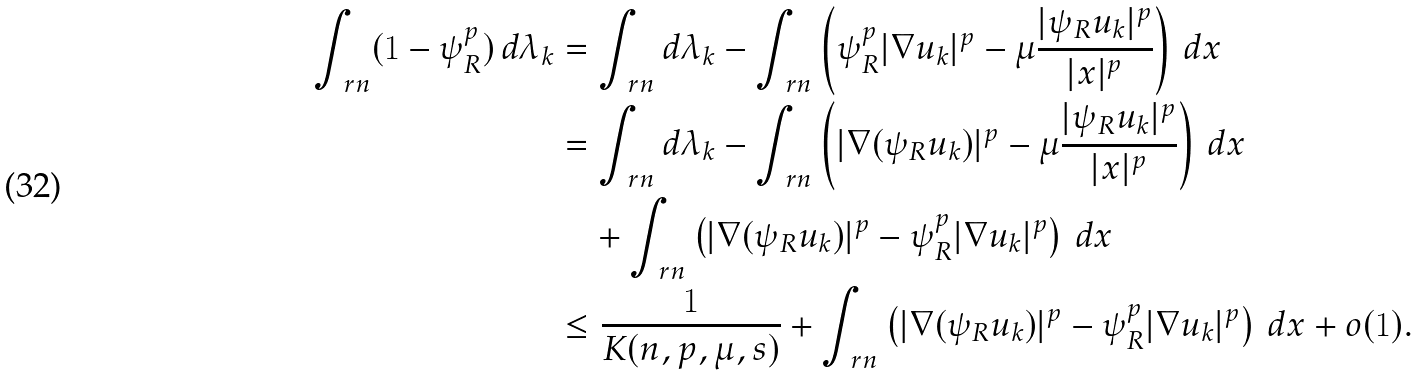<formula> <loc_0><loc_0><loc_500><loc_500>\int _ { \ r n } ( 1 - \psi _ { R } ^ { p } ) \, d \lambda _ { k } & = \int _ { \ r n } d \lambda _ { k } - \int _ { \ r n } \left ( \psi _ { R } ^ { p } | \nabla u _ { k } | ^ { p } - \mu \frac { | \psi _ { R } u _ { k } | ^ { p } } { | x | ^ { p } } \right ) \, d x \\ & = \int _ { \ r n } d \lambda _ { k } - \int _ { \ r n } \left ( | \nabla ( \psi _ { R } u _ { k } ) | ^ { p } - \mu \frac { | \psi _ { R } u _ { k } | ^ { p } } { | x | ^ { p } } \right ) \, d x \\ & \quad + \int _ { \ r n } \left ( | \nabla ( \psi _ { R } u _ { k } ) | ^ { p } - \psi _ { R } ^ { p } | \nabla u _ { k } | ^ { p } \right ) \, d x \\ & \leq \frac { 1 } { K ( n , p , \mu , s ) } + \int _ { \ r n } \left ( | \nabla ( \psi _ { R } u _ { k } ) | ^ { p } - \psi _ { R } ^ { p } | \nabla u _ { k } | ^ { p } \right ) \, d x + o ( 1 ) .</formula> 